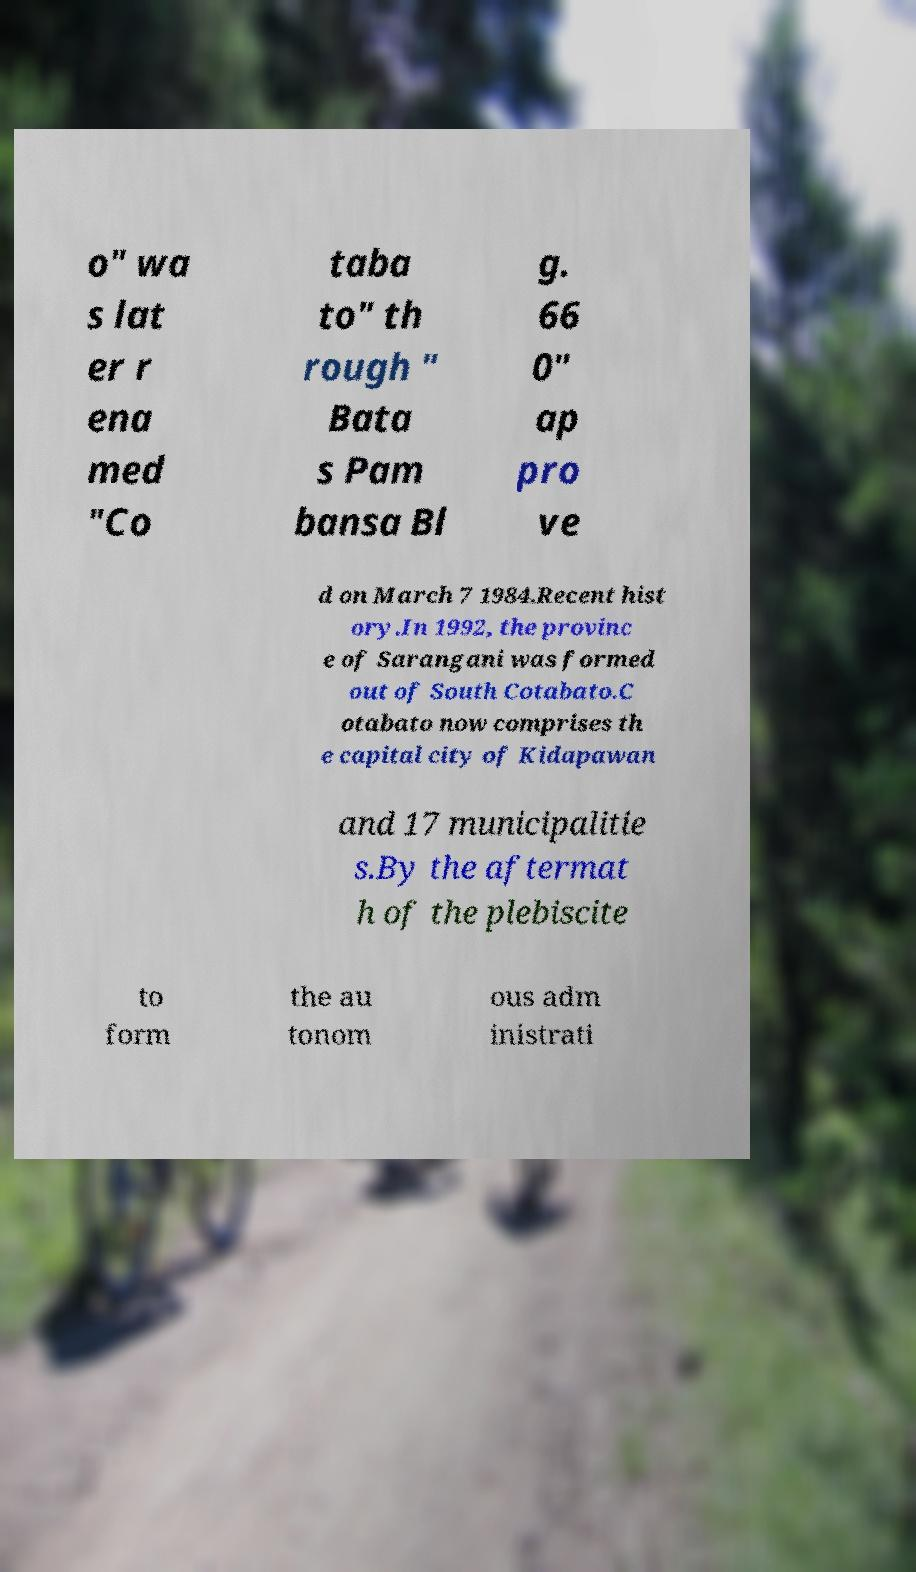What messages or text are displayed in this image? I need them in a readable, typed format. o" wa s lat er r ena med "Co taba to" th rough " Bata s Pam bansa Bl g. 66 0" ap pro ve d on March 7 1984.Recent hist ory.In 1992, the provinc e of Sarangani was formed out of South Cotabato.C otabato now comprises th e capital city of Kidapawan and 17 municipalitie s.By the aftermat h of the plebiscite to form the au tonom ous adm inistrati 